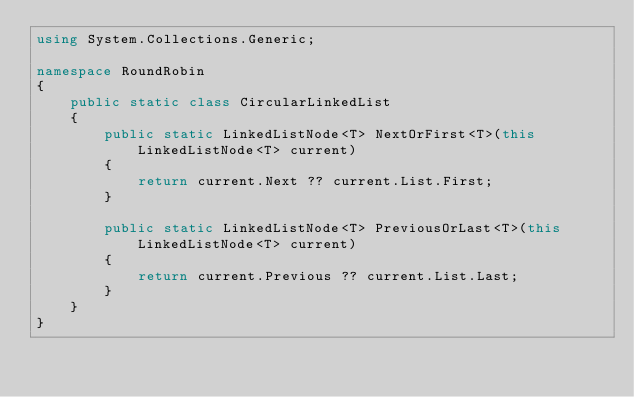Convert code to text. <code><loc_0><loc_0><loc_500><loc_500><_C#_>using System.Collections.Generic;

namespace RoundRobin
{
    public static class CircularLinkedList
    {
        public static LinkedListNode<T> NextOrFirst<T>(this LinkedListNode<T> current)
        {
            return current.Next ?? current.List.First;
        }

        public static LinkedListNode<T> PreviousOrLast<T>(this LinkedListNode<T> current)
        {
            return current.Previous ?? current.List.Last;
        }
    }
}</code> 